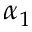<formula> <loc_0><loc_0><loc_500><loc_500>\alpha _ { 1 }</formula> 